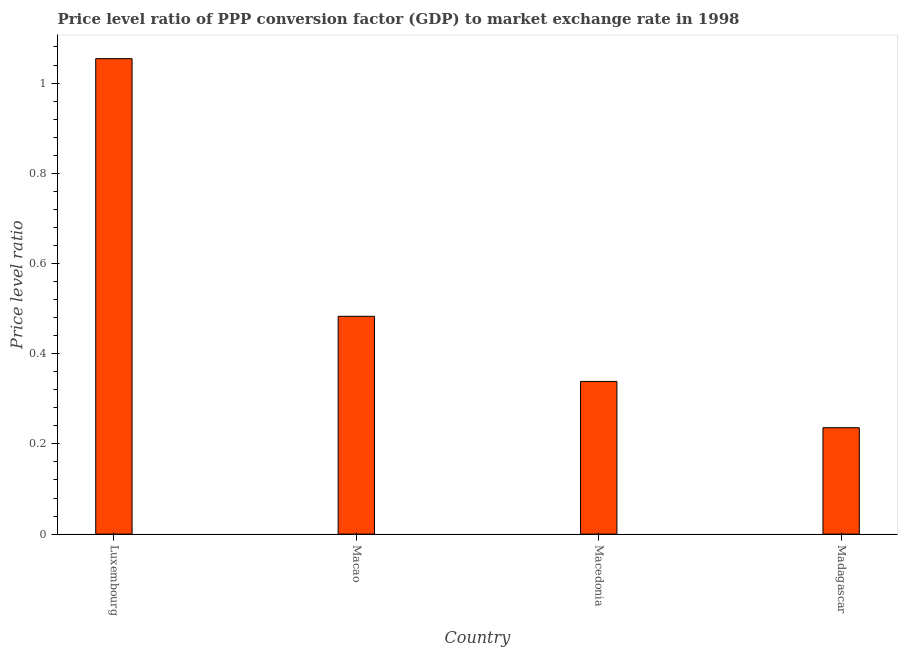Does the graph contain any zero values?
Provide a succinct answer. No. What is the title of the graph?
Provide a succinct answer. Price level ratio of PPP conversion factor (GDP) to market exchange rate in 1998. What is the label or title of the X-axis?
Ensure brevity in your answer.  Country. What is the label or title of the Y-axis?
Offer a very short reply. Price level ratio. What is the price level ratio in Madagascar?
Provide a succinct answer. 0.24. Across all countries, what is the maximum price level ratio?
Your answer should be very brief. 1.05. Across all countries, what is the minimum price level ratio?
Your answer should be very brief. 0.24. In which country was the price level ratio maximum?
Your response must be concise. Luxembourg. In which country was the price level ratio minimum?
Offer a very short reply. Madagascar. What is the sum of the price level ratio?
Your response must be concise. 2.11. What is the difference between the price level ratio in Macao and Macedonia?
Give a very brief answer. 0.14. What is the average price level ratio per country?
Give a very brief answer. 0.53. What is the median price level ratio?
Provide a succinct answer. 0.41. What is the ratio of the price level ratio in Macedonia to that in Madagascar?
Keep it short and to the point. 1.44. Is the price level ratio in Macao less than that in Madagascar?
Make the answer very short. No. Is the difference between the price level ratio in Luxembourg and Madagascar greater than the difference between any two countries?
Your answer should be very brief. Yes. What is the difference between the highest and the second highest price level ratio?
Give a very brief answer. 0.57. What is the difference between the highest and the lowest price level ratio?
Offer a terse response. 0.82. Are all the bars in the graph horizontal?
Ensure brevity in your answer.  No. What is the difference between two consecutive major ticks on the Y-axis?
Your response must be concise. 0.2. What is the Price level ratio of Luxembourg?
Keep it short and to the point. 1.05. What is the Price level ratio of Macao?
Provide a succinct answer. 0.48. What is the Price level ratio in Macedonia?
Make the answer very short. 0.34. What is the Price level ratio of Madagascar?
Your answer should be compact. 0.24. What is the difference between the Price level ratio in Luxembourg and Macao?
Provide a short and direct response. 0.57. What is the difference between the Price level ratio in Luxembourg and Macedonia?
Your answer should be compact. 0.72. What is the difference between the Price level ratio in Luxembourg and Madagascar?
Offer a very short reply. 0.82. What is the difference between the Price level ratio in Macao and Macedonia?
Offer a very short reply. 0.14. What is the difference between the Price level ratio in Macao and Madagascar?
Your answer should be very brief. 0.25. What is the difference between the Price level ratio in Macedonia and Madagascar?
Keep it short and to the point. 0.1. What is the ratio of the Price level ratio in Luxembourg to that in Macao?
Your answer should be compact. 2.18. What is the ratio of the Price level ratio in Luxembourg to that in Macedonia?
Offer a terse response. 3.11. What is the ratio of the Price level ratio in Luxembourg to that in Madagascar?
Offer a terse response. 4.47. What is the ratio of the Price level ratio in Macao to that in Macedonia?
Offer a very short reply. 1.43. What is the ratio of the Price level ratio in Macao to that in Madagascar?
Offer a very short reply. 2.05. What is the ratio of the Price level ratio in Macedonia to that in Madagascar?
Your answer should be very brief. 1.44. 